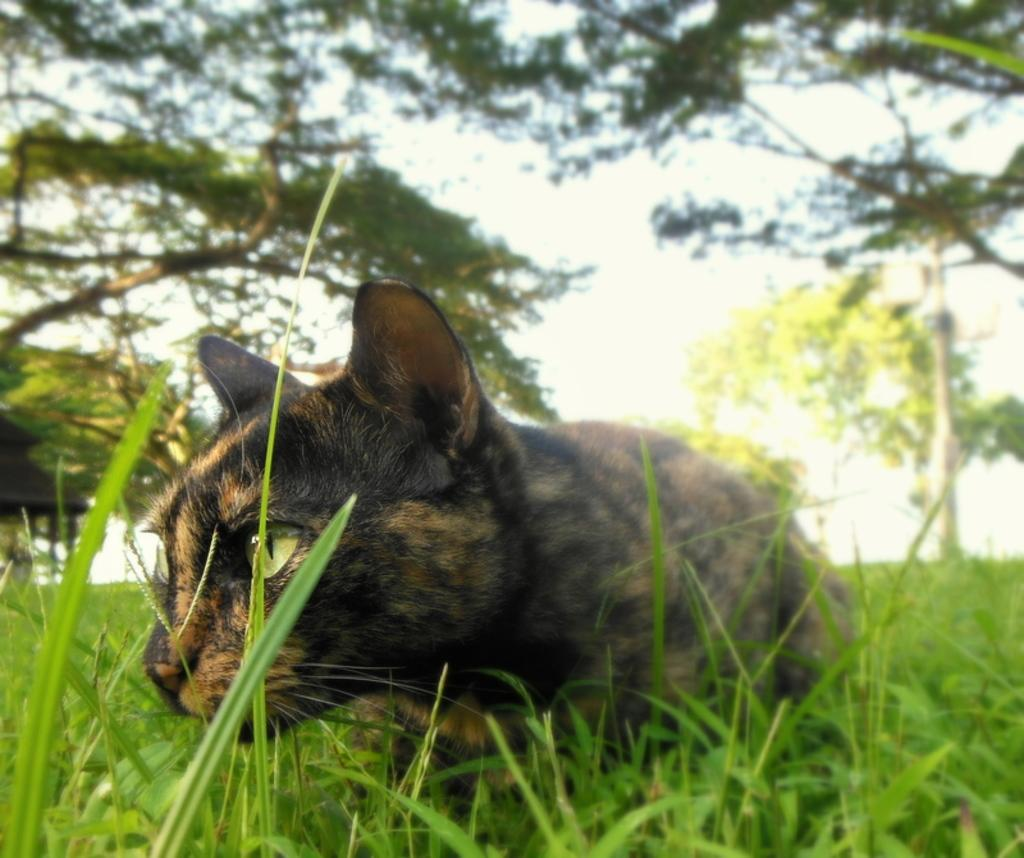What is the main subject in the foreground of the image? There is a cat in the foreground of the image. What type of vegetation is present at the bottom of the image? There is grass at the bottom of the image. What can be seen in the background of the image? There are trees and the sky visible in the background of the image. How many children are playing with the pail in the image? There are no children or pails present in the image. 